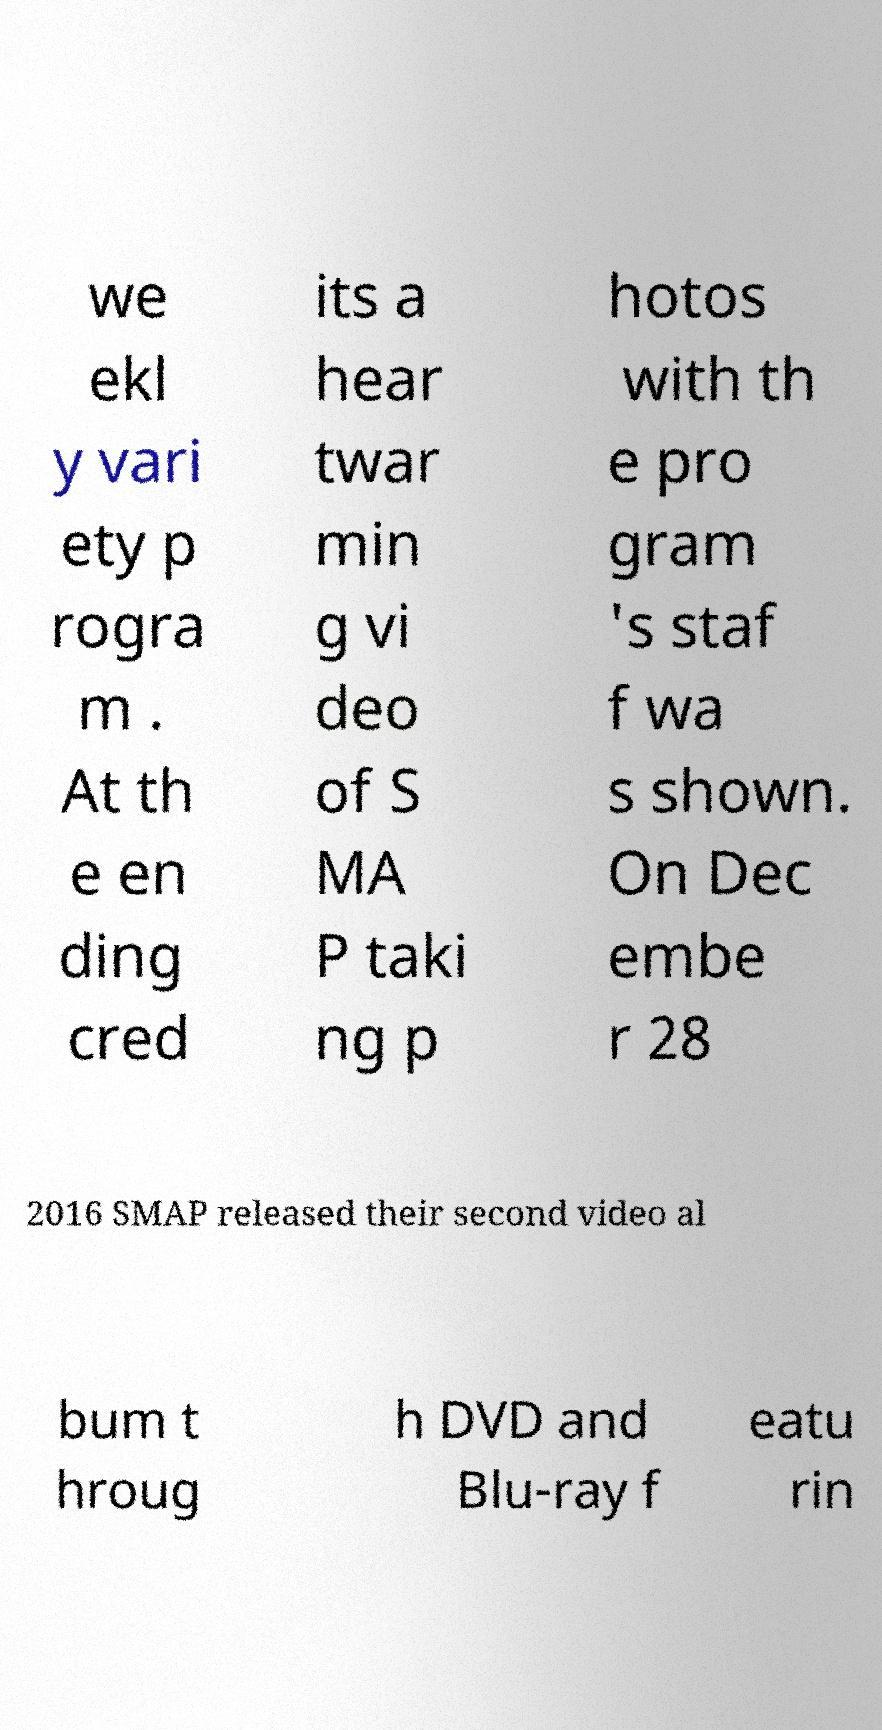There's text embedded in this image that I need extracted. Can you transcribe it verbatim? we ekl y vari ety p rogra m . At th e en ding cred its a hear twar min g vi deo of S MA P taki ng p hotos with th e pro gram 's staf f wa s shown. On Dec embe r 28 2016 SMAP released their second video al bum t hroug h DVD and Blu-ray f eatu rin 